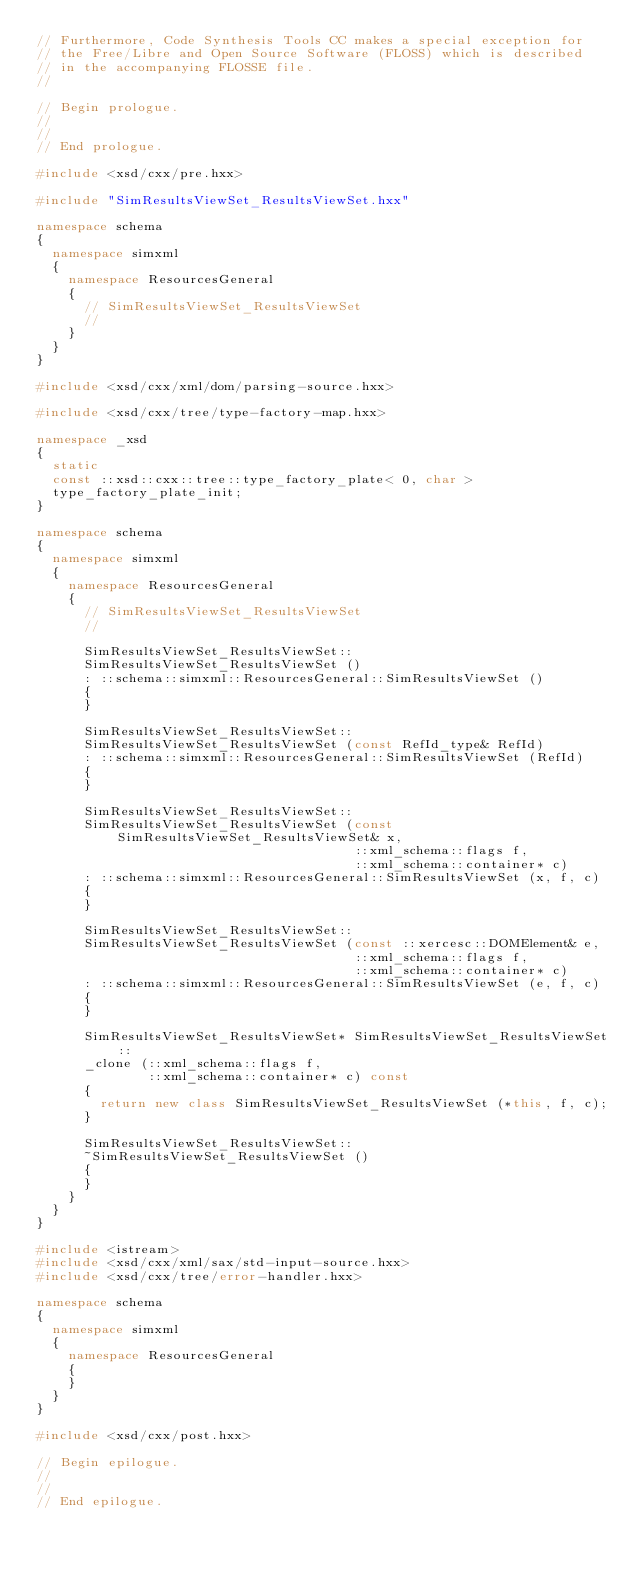<code> <loc_0><loc_0><loc_500><loc_500><_C++_>// Furthermore, Code Synthesis Tools CC makes a special exception for
// the Free/Libre and Open Source Software (FLOSS) which is described
// in the accompanying FLOSSE file.
//

// Begin prologue.
//
//
// End prologue.

#include <xsd/cxx/pre.hxx>

#include "SimResultsViewSet_ResultsViewSet.hxx"

namespace schema
{
  namespace simxml
  {
    namespace ResourcesGeneral
    {
      // SimResultsViewSet_ResultsViewSet
      // 
    }
  }
}

#include <xsd/cxx/xml/dom/parsing-source.hxx>

#include <xsd/cxx/tree/type-factory-map.hxx>

namespace _xsd
{
  static
  const ::xsd::cxx::tree::type_factory_plate< 0, char >
  type_factory_plate_init;
}

namespace schema
{
  namespace simxml
  {
    namespace ResourcesGeneral
    {
      // SimResultsViewSet_ResultsViewSet
      //

      SimResultsViewSet_ResultsViewSet::
      SimResultsViewSet_ResultsViewSet ()
      : ::schema::simxml::ResourcesGeneral::SimResultsViewSet ()
      {
      }

      SimResultsViewSet_ResultsViewSet::
      SimResultsViewSet_ResultsViewSet (const RefId_type& RefId)
      : ::schema::simxml::ResourcesGeneral::SimResultsViewSet (RefId)
      {
      }

      SimResultsViewSet_ResultsViewSet::
      SimResultsViewSet_ResultsViewSet (const SimResultsViewSet_ResultsViewSet& x,
                                        ::xml_schema::flags f,
                                        ::xml_schema::container* c)
      : ::schema::simxml::ResourcesGeneral::SimResultsViewSet (x, f, c)
      {
      }

      SimResultsViewSet_ResultsViewSet::
      SimResultsViewSet_ResultsViewSet (const ::xercesc::DOMElement& e,
                                        ::xml_schema::flags f,
                                        ::xml_schema::container* c)
      : ::schema::simxml::ResourcesGeneral::SimResultsViewSet (e, f, c)
      {
      }

      SimResultsViewSet_ResultsViewSet* SimResultsViewSet_ResultsViewSet::
      _clone (::xml_schema::flags f,
              ::xml_schema::container* c) const
      {
        return new class SimResultsViewSet_ResultsViewSet (*this, f, c);
      }

      SimResultsViewSet_ResultsViewSet::
      ~SimResultsViewSet_ResultsViewSet ()
      {
      }
    }
  }
}

#include <istream>
#include <xsd/cxx/xml/sax/std-input-source.hxx>
#include <xsd/cxx/tree/error-handler.hxx>

namespace schema
{
  namespace simxml
  {
    namespace ResourcesGeneral
    {
    }
  }
}

#include <xsd/cxx/post.hxx>

// Begin epilogue.
//
//
// End epilogue.

</code> 